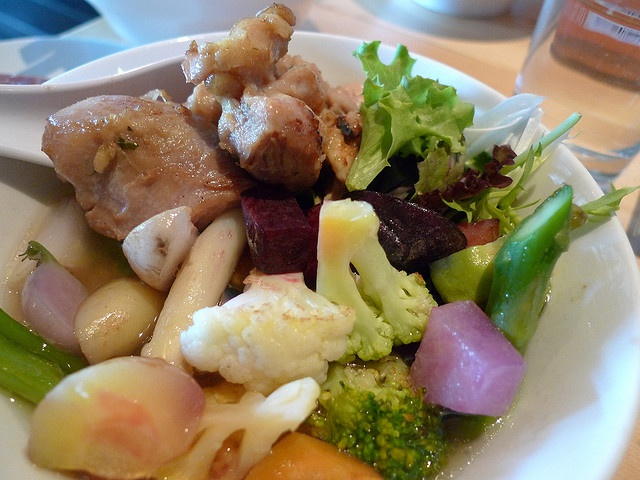Describe the objects in this image and their specific colors. I can see bowl in blue, tan, olive, darkgray, and black tones, cup in blue, tan, brown, and darkgray tones, broccoli in blue, olive, and darkgreen tones, broccoli in blue, tan, and olive tones, and spoon in blue, gray, darkgray, and lightgray tones in this image. 